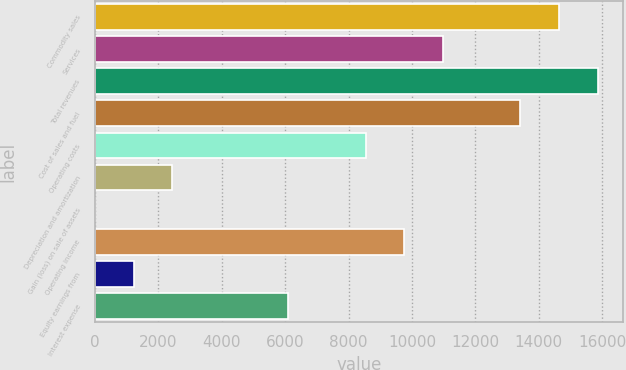Convert chart to OTSL. <chart><loc_0><loc_0><loc_500><loc_500><bar_chart><fcel>Commodity sales<fcel>Services<fcel>Total revenues<fcel>Cost of sales and fuel<fcel>Operating costs<fcel>Depreciation and amortization<fcel>Gain (loss) on sale of assets<fcel>Operating income<fcel>Equity earnings from<fcel>Interest expense<nl><fcel>14632.8<fcel>10976.2<fcel>15851.6<fcel>13414<fcel>8538.55<fcel>2444.3<fcel>6.6<fcel>9757.4<fcel>1225.45<fcel>6100.85<nl></chart> 